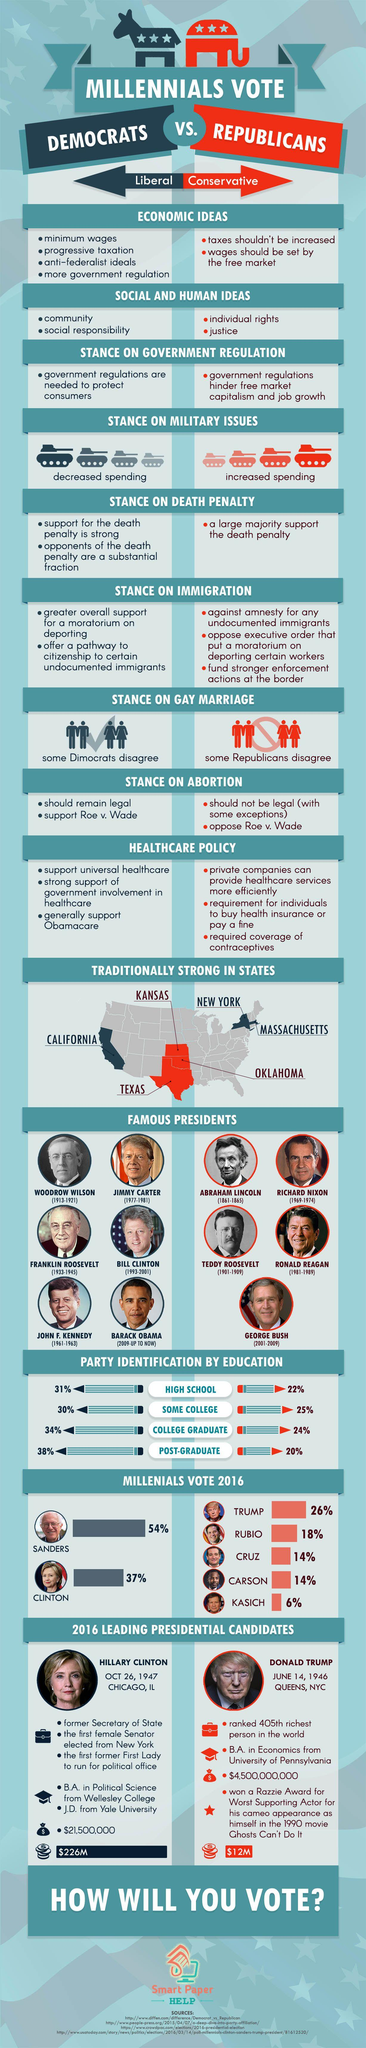Give some essential details in this illustration. Hillary Clinton was born in Chicago, Illinois. Abraham Lincoln served as the President of the United States from 1861 to 1865, a period characterized by the country's Civil War. Millennials voted for Hillary Clinton in 2016 at a rate of 37%. George Bush served as the President of the United States from 2001 to 2009. Donald Trump was born on June 14, 1946. 